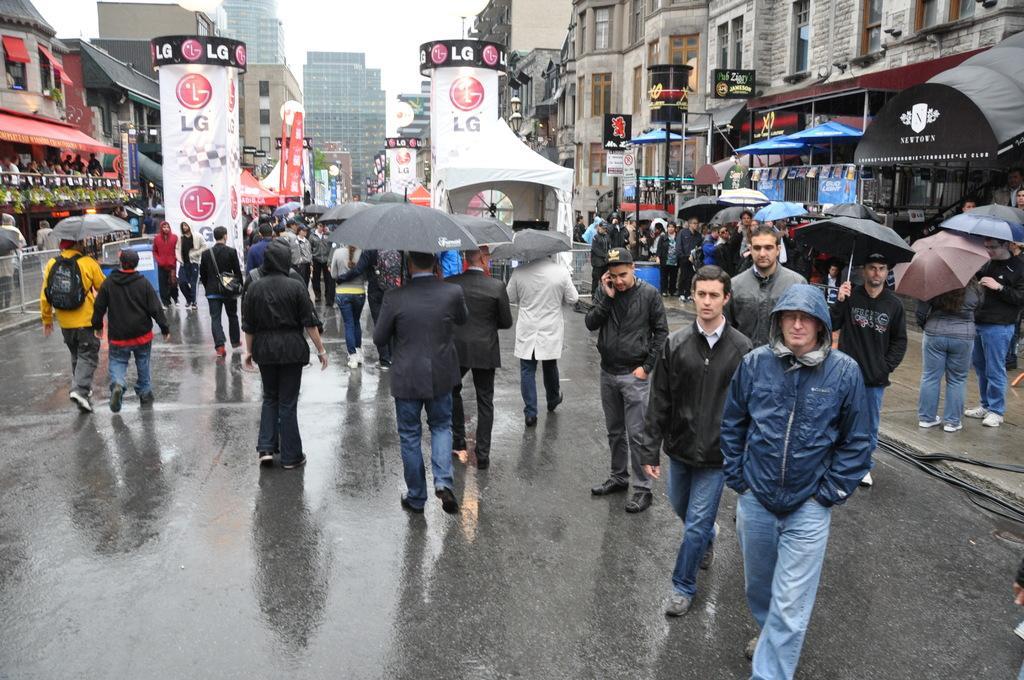Please provide a concise description of this image. In this picture I can see few buildings and few people walking and few are holding umbrellas in their hands and I can see few people standing and I can see advertisement hoardings and a cloudy sky. 